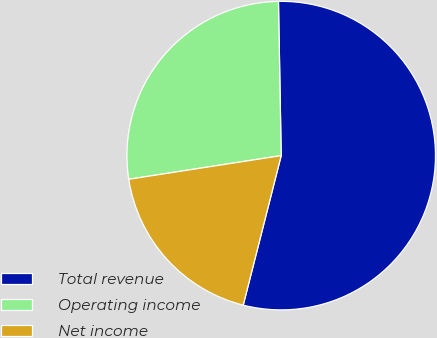Convert chart to OTSL. <chart><loc_0><loc_0><loc_500><loc_500><pie_chart><fcel>Total revenue<fcel>Operating income<fcel>Net income<nl><fcel>54.24%<fcel>27.17%<fcel>18.59%<nl></chart> 